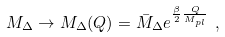Convert formula to latex. <formula><loc_0><loc_0><loc_500><loc_500>M _ { \Delta } \rightarrow M _ { \Delta } ( Q ) = \bar { M } _ { \Delta } e ^ { \frac { \beta } { 2 } \frac { Q } { M _ { p l } } } \ ,</formula> 